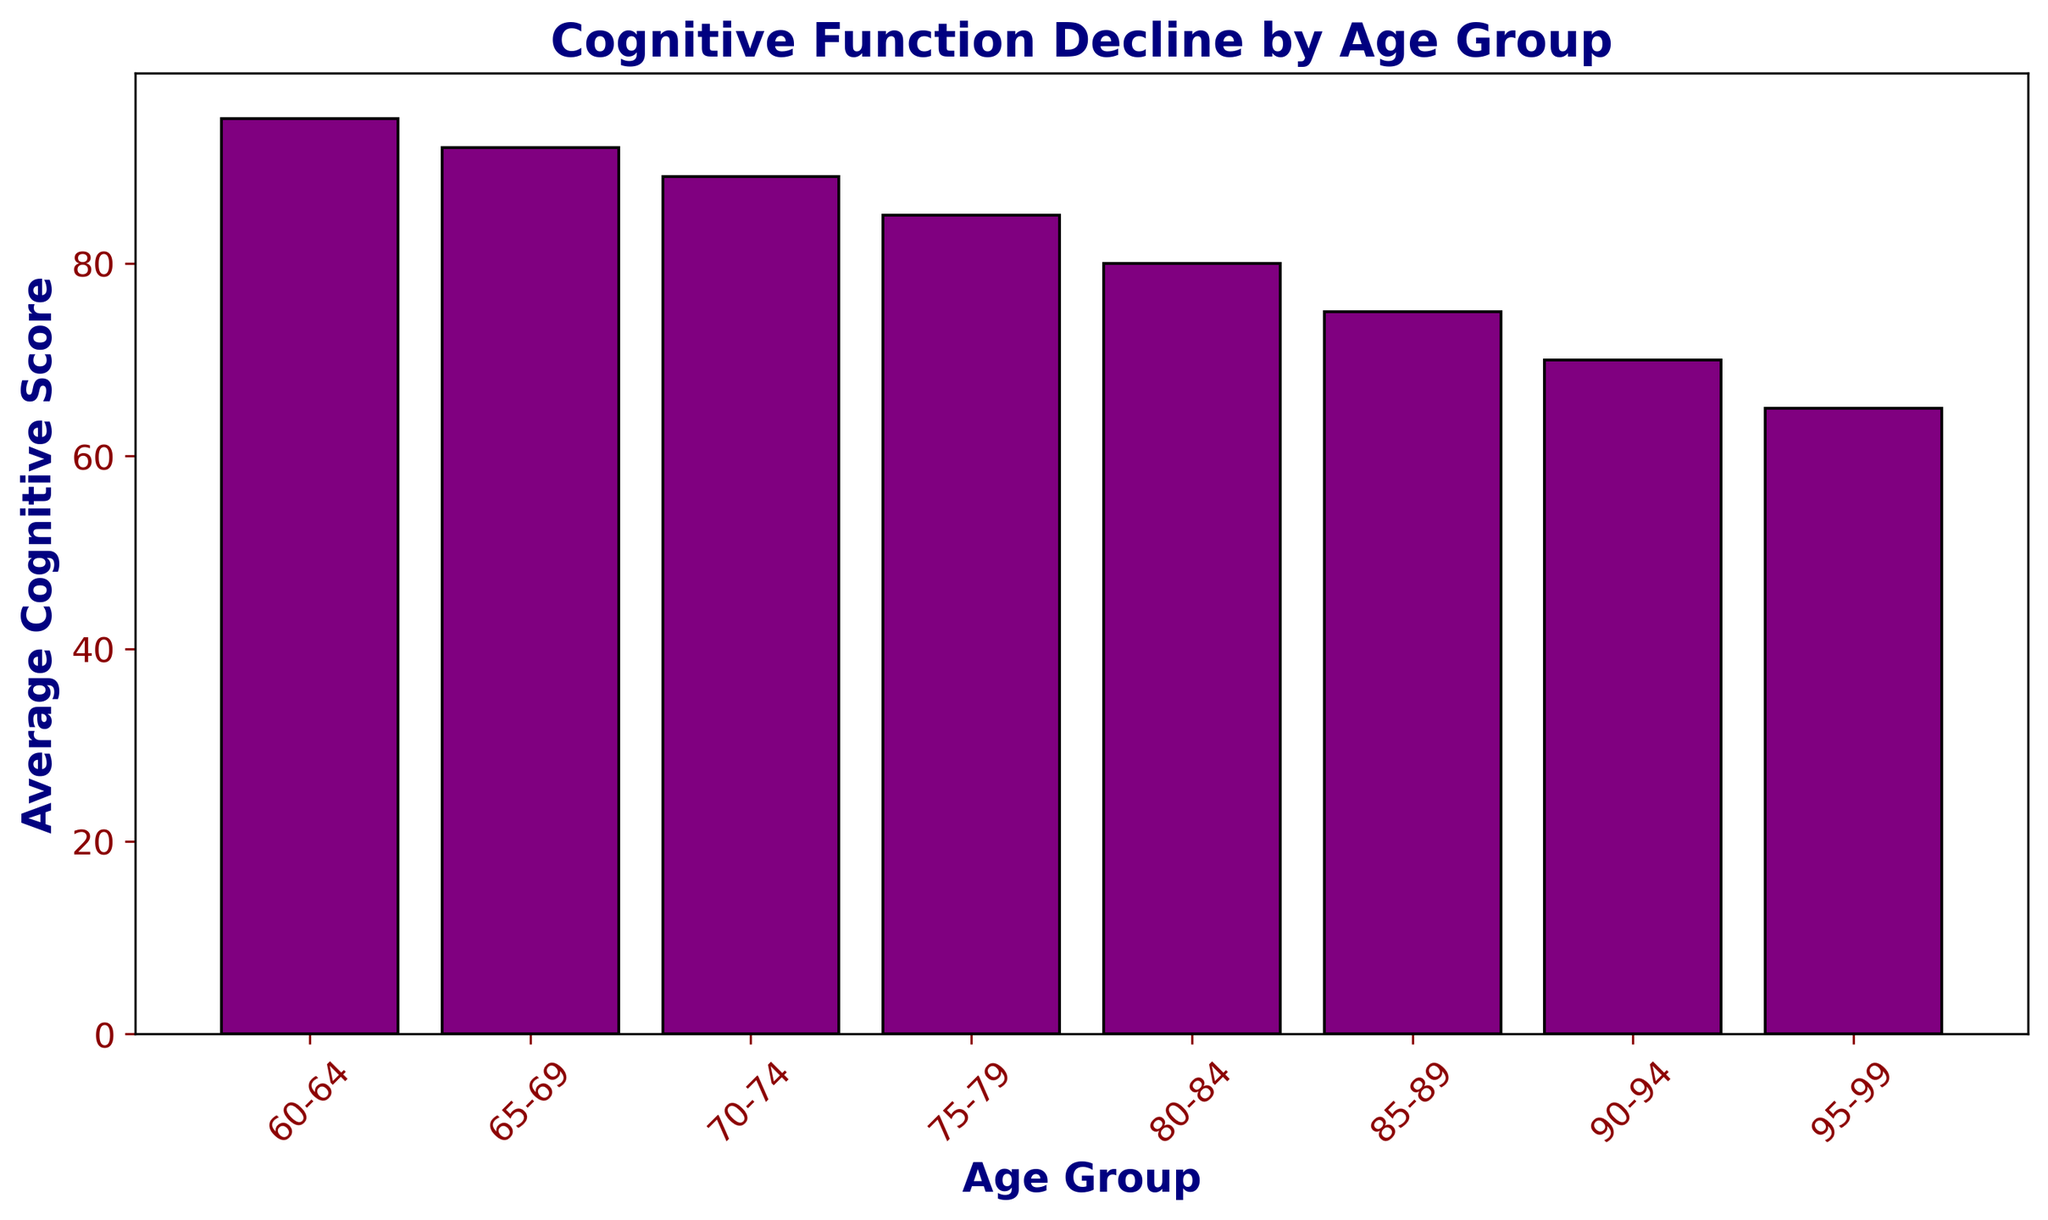Which age group has the highest average cognitive score? The age group with the highest average cognitive score is the one with the tallest bar. In this figure, the tallest bar corresponds to the 60-64 age group.
Answer: 60-64 How does the average cognitive score change from the 65-69 age group to the 70-74 age group? To find the change in cognitive score, subtract the average score of the 70-74 age group from that of the 65-69 group. The scores are 92 and 89 respectively, so the change is 92 - 89.
Answer: 3 What is the sum of the average cognitive scores for the age groups between 80 and 89? To find this sum, add the average cognitive scores for the 80-84 and 85-89 age groups. The scores are 80 and 75 respectively, the sum is 80 + 75.
Answer: 155 What is the difference in cognitive score between the youngest and oldest age groups? The youngest group (60-64) has an average score of 95, and the oldest group (95-99) has a score of 65. Calculate the difference: 95 - 65.
Answer: 30 Compare the average cognitive scores of age groups 70-74 and 90-94. Which has the lower score? By comparing the heights of the bars, the 70-74 age group has an average score of 89, and the 90-94 age group has a score of 70. Since 70 is less than 89, the 90-94 group has the lower score.
Answer: 90-94 Which age group shows the steepest decline in average cognitive score from the previous age group? To identify this, look for the largest vertical difference between consecutive bars. From the 80-84 group (80) to the 85-89 group (75), the decline is 5, which is the largest observed decline.
Answer: 85-89 By how many points does the average cognitive score decrease from the 75-79 age group to the 95-99 age group? The cognitive score for the 75-79 age group is 85, and for the 95-99 age group, it is 65. Subtract: 85 - 65.
Answer: 20 What is the average cognitive score for the age groups from 70-79? Add the scores of the 70-74 (89) and 75-79 (85) groups, then divide by 2. So, (89 + 85) / 2.
Answer: 87 If you visually compare the bars' colors in the chart, which color is primarily used? The bars in the chart are primarily colored purple.
Answer: Purple 